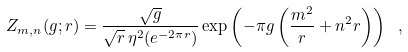<formula> <loc_0><loc_0><loc_500><loc_500>Z _ { m , n } ( g ; r ) = \frac { \sqrt { g } } { \sqrt { r } \, \eta ^ { 2 } ( e ^ { - 2 \pi r } ) } \exp \left ( - \pi g \left ( \frac { m ^ { 2 } } { r } + n ^ { 2 } r \right ) \right ) \ ,</formula> 